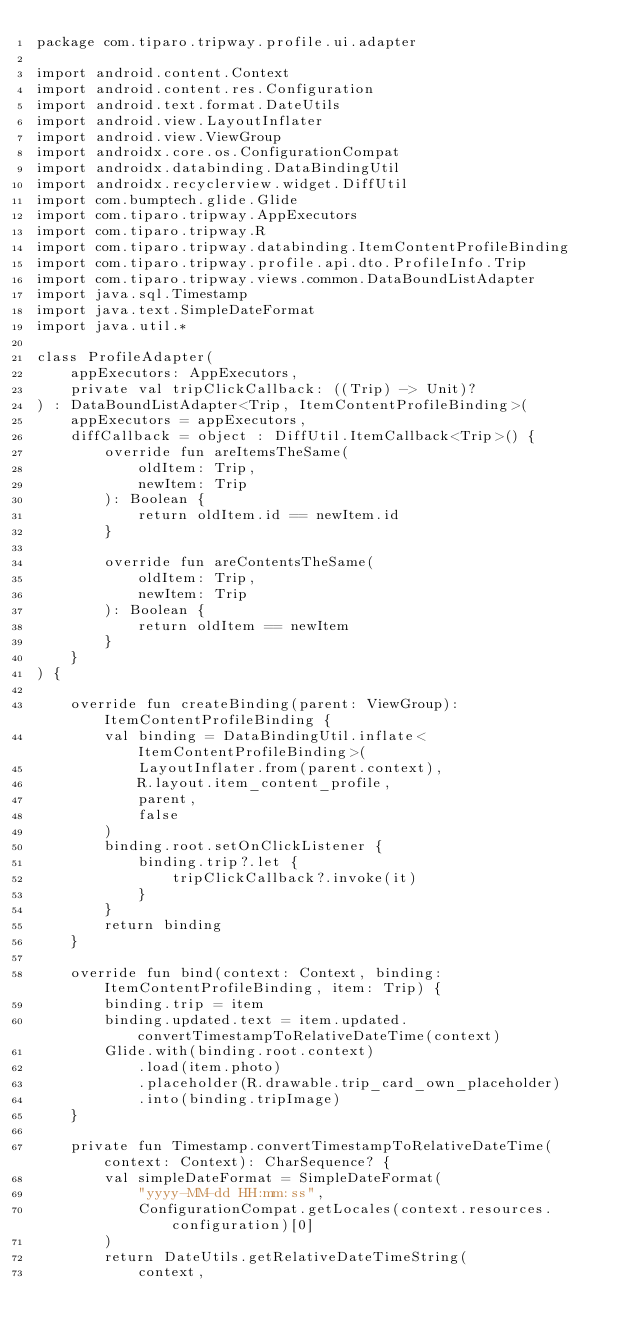<code> <loc_0><loc_0><loc_500><loc_500><_Kotlin_>package com.tiparo.tripway.profile.ui.adapter

import android.content.Context
import android.content.res.Configuration
import android.text.format.DateUtils
import android.view.LayoutInflater
import android.view.ViewGroup
import androidx.core.os.ConfigurationCompat
import androidx.databinding.DataBindingUtil
import androidx.recyclerview.widget.DiffUtil
import com.bumptech.glide.Glide
import com.tiparo.tripway.AppExecutors
import com.tiparo.tripway.R
import com.tiparo.tripway.databinding.ItemContentProfileBinding
import com.tiparo.tripway.profile.api.dto.ProfileInfo.Trip
import com.tiparo.tripway.views.common.DataBoundListAdapter
import java.sql.Timestamp
import java.text.SimpleDateFormat
import java.util.*

class ProfileAdapter(
    appExecutors: AppExecutors,
    private val tripClickCallback: ((Trip) -> Unit)?
) : DataBoundListAdapter<Trip, ItemContentProfileBinding>(
    appExecutors = appExecutors,
    diffCallback = object : DiffUtil.ItemCallback<Trip>() {
        override fun areItemsTheSame(
            oldItem: Trip,
            newItem: Trip
        ): Boolean {
            return oldItem.id == newItem.id
        }

        override fun areContentsTheSame(
            oldItem: Trip,
            newItem: Trip
        ): Boolean {
            return oldItem == newItem
        }
    }
) {

    override fun createBinding(parent: ViewGroup): ItemContentProfileBinding {
        val binding = DataBindingUtil.inflate<ItemContentProfileBinding>(
            LayoutInflater.from(parent.context),
            R.layout.item_content_profile,
            parent,
            false
        )
        binding.root.setOnClickListener {
            binding.trip?.let {
                tripClickCallback?.invoke(it)
            }
        }
        return binding
    }

    override fun bind(context: Context, binding: ItemContentProfileBinding, item: Trip) {
        binding.trip = item
        binding.updated.text = item.updated.convertTimestampToRelativeDateTime(context)
        Glide.with(binding.root.context)
            .load(item.photo)
            .placeholder(R.drawable.trip_card_own_placeholder)
            .into(binding.tripImage)
    }

    private fun Timestamp.convertTimestampToRelativeDateTime(context: Context): CharSequence? {
        val simpleDateFormat = SimpleDateFormat(
            "yyyy-MM-dd HH:mm:ss",
            ConfigurationCompat.getLocales(context.resources.configuration)[0]
        )
        return DateUtils.getRelativeDateTimeString(
            context,</code> 